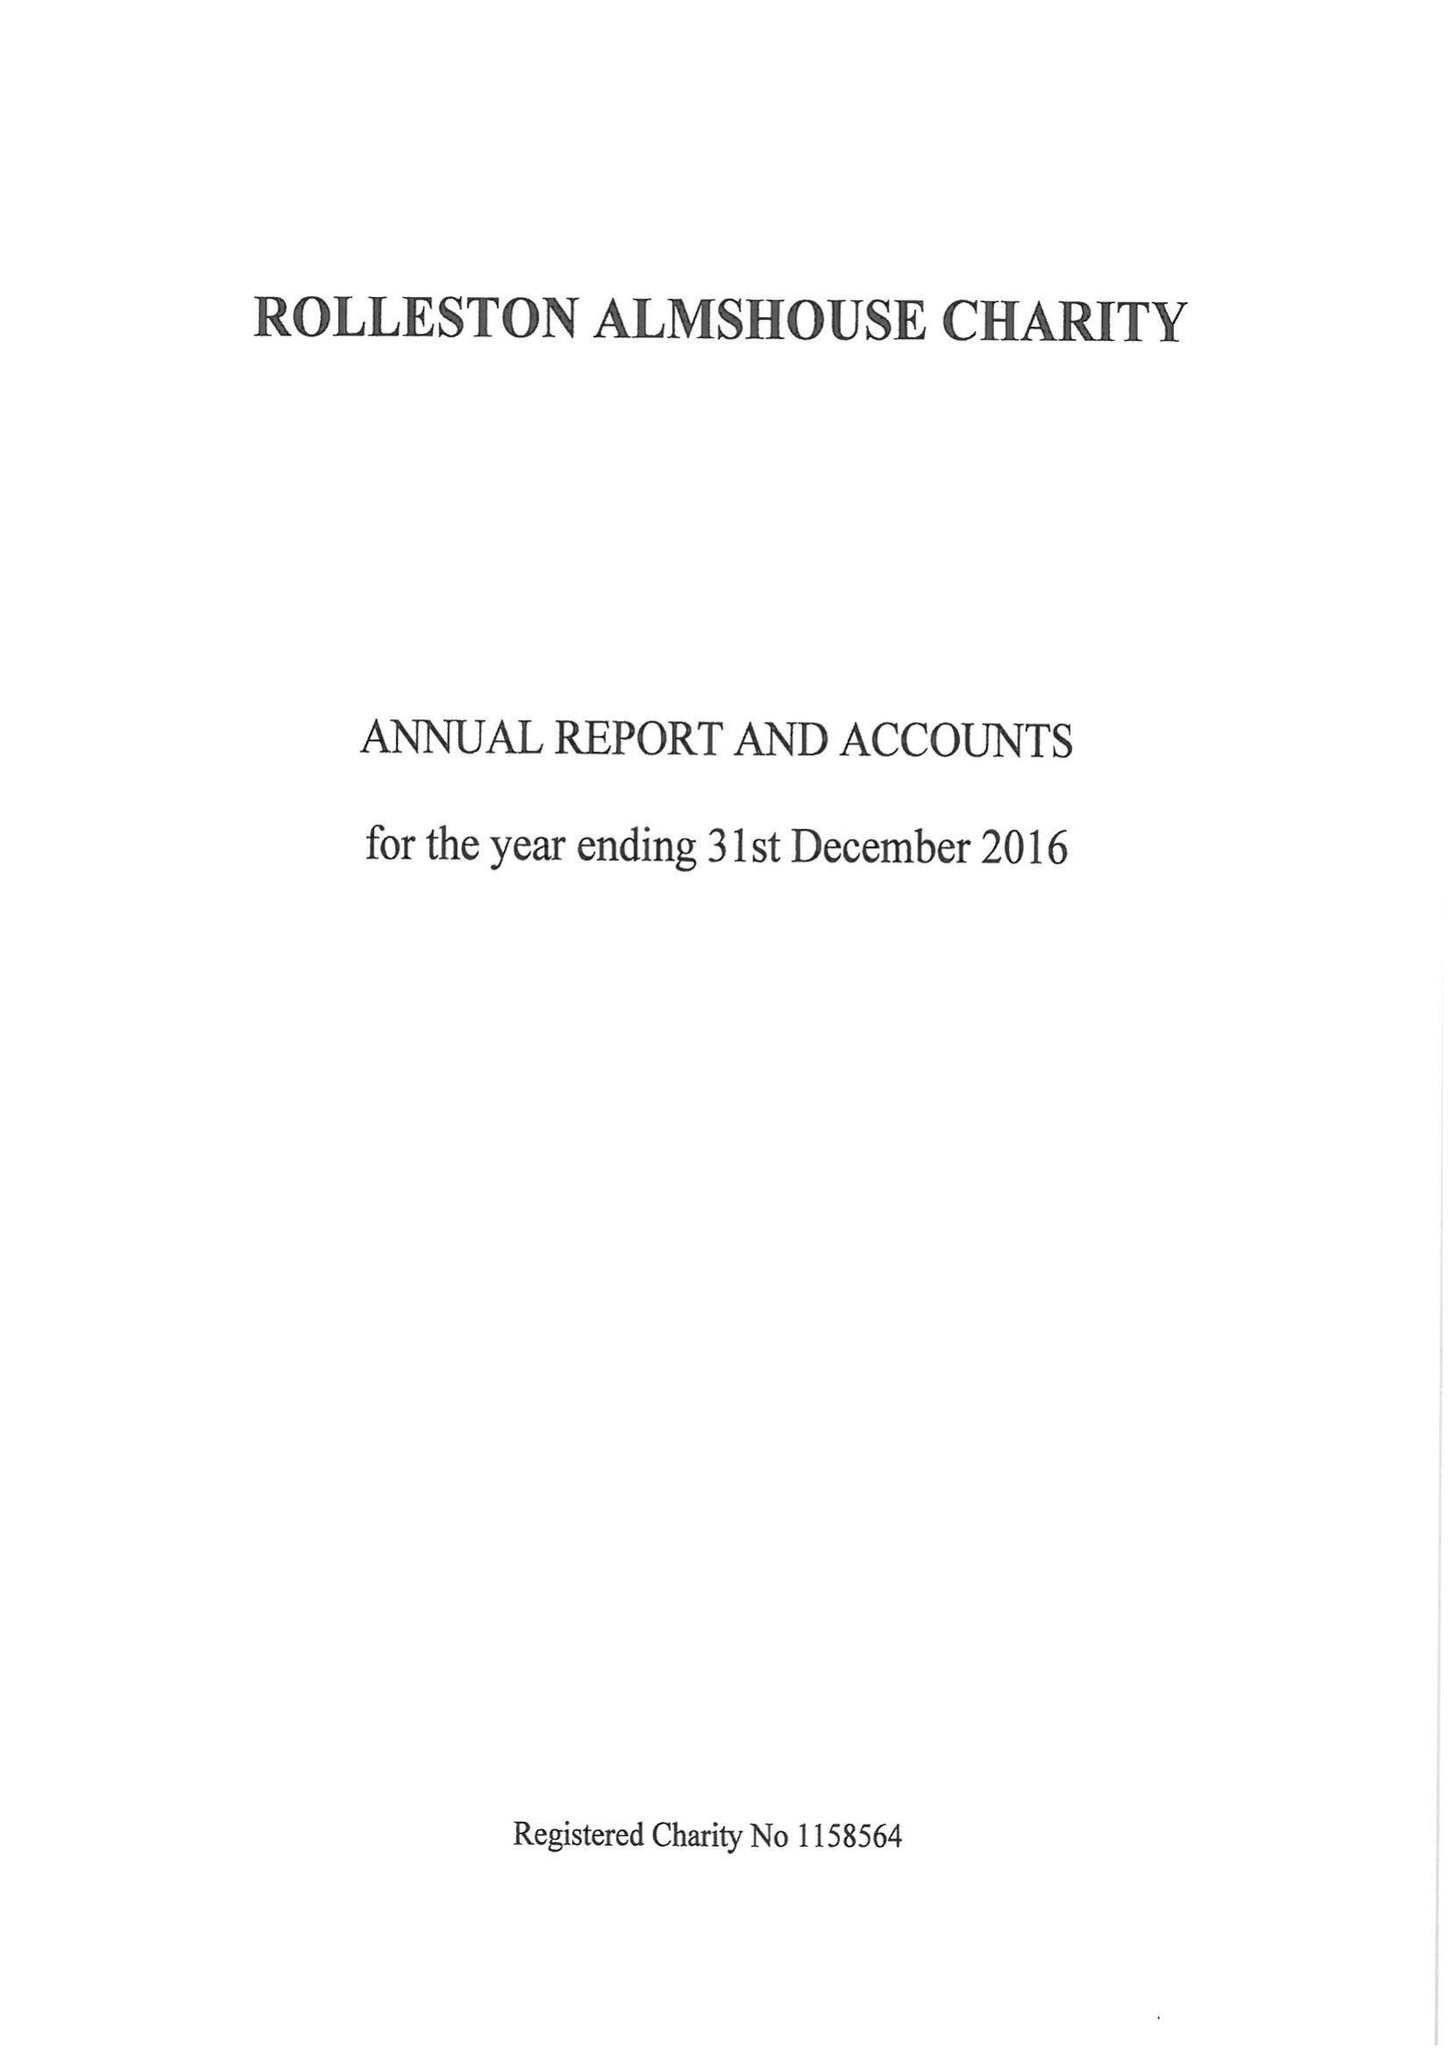What is the value for the spending_annually_in_british_pounds?
Answer the question using a single word or phrase. 13496.00 